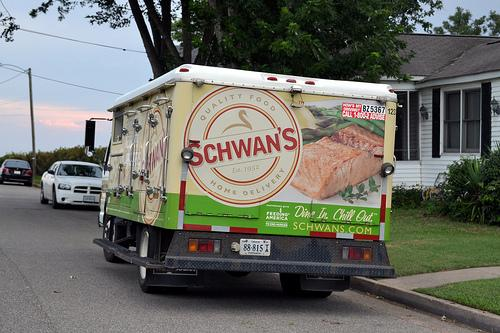What are the colors and state of the food delivery truck's tires and rearview mirror? The tires of the truck are black, and the rearview mirror appears to be intact and functioning. Describe the main vehicle in the image and its purpose. A medium-sized, yellow and green food delivery truck with a swan logo and advertising for various food items is parked in front of a house. Describe the state of the street and the surrounding nature in the image. The street is gray, with neatly cut green grass and a sidewalk on the right side of the food delivery truck. Provide a brief overview of the scene in the image. A food delivery truck is parked on a street, along with two cars, with a white house featuring black shutters in the background. What are the two models of the cars parked in the image? There is a white sedan and a black sedan parked on the street. Provide a short description of the cars parked on the street. A small white sedan and a small black sedan are parked on the street in front of the food delivery truck. What types of advertisements can be seen on the food delivery truck? There are depictions of salmon fillet, asparagus, and a big round logo featuring a swan on the back of the food delivery truck. What type of house is in the image and what distinguishes it? A white wooden house with black shutters, a brown roof, and a black lamp mounted on the outside wall. Mention the colors of the main objects in the image. The image has a white and a black car, a yellow and green truck, a white house with black shutters, and green grass. List the main elements present in the image. Food delivery truck, white house, black and white sedans, green grass, sidewalk, and a broken street light. 